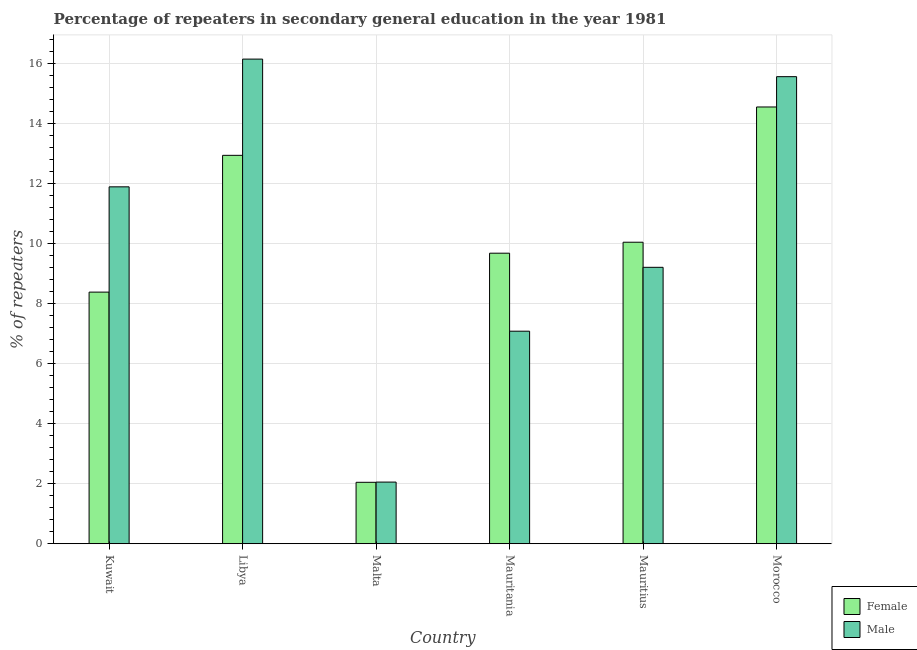How many groups of bars are there?
Give a very brief answer. 6. Are the number of bars on each tick of the X-axis equal?
Your response must be concise. Yes. How many bars are there on the 3rd tick from the left?
Ensure brevity in your answer.  2. What is the label of the 4th group of bars from the left?
Make the answer very short. Mauritania. In how many cases, is the number of bars for a given country not equal to the number of legend labels?
Provide a succinct answer. 0. What is the percentage of male repeaters in Malta?
Provide a succinct answer. 2.05. Across all countries, what is the maximum percentage of male repeaters?
Make the answer very short. 16.13. Across all countries, what is the minimum percentage of female repeaters?
Make the answer very short. 2.05. In which country was the percentage of female repeaters maximum?
Your response must be concise. Morocco. In which country was the percentage of female repeaters minimum?
Keep it short and to the point. Malta. What is the total percentage of male repeaters in the graph?
Give a very brief answer. 61.89. What is the difference between the percentage of male repeaters in Kuwait and that in Mauritius?
Offer a terse response. 2.68. What is the difference between the percentage of female repeaters in Mauritania and the percentage of male repeaters in Morocco?
Ensure brevity in your answer.  -5.88. What is the average percentage of male repeaters per country?
Ensure brevity in your answer.  10.32. What is the difference between the percentage of female repeaters and percentage of male repeaters in Malta?
Provide a short and direct response. -0.01. In how many countries, is the percentage of male repeaters greater than 14.8 %?
Ensure brevity in your answer.  2. What is the ratio of the percentage of male repeaters in Libya to that in Malta?
Ensure brevity in your answer.  7.86. Is the percentage of female repeaters in Kuwait less than that in Morocco?
Provide a succinct answer. Yes. What is the difference between the highest and the second highest percentage of male repeaters?
Make the answer very short. 0.58. What is the difference between the highest and the lowest percentage of female repeaters?
Offer a very short reply. 12.49. Are all the bars in the graph horizontal?
Provide a succinct answer. No. How many countries are there in the graph?
Make the answer very short. 6. What is the difference between two consecutive major ticks on the Y-axis?
Give a very brief answer. 2. Are the values on the major ticks of Y-axis written in scientific E-notation?
Provide a short and direct response. No. Does the graph contain any zero values?
Your answer should be very brief. No. What is the title of the graph?
Make the answer very short. Percentage of repeaters in secondary general education in the year 1981. Does "By country of asylum" appear as one of the legend labels in the graph?
Make the answer very short. No. What is the label or title of the X-axis?
Provide a short and direct response. Country. What is the label or title of the Y-axis?
Provide a short and direct response. % of repeaters. What is the % of repeaters of Female in Kuwait?
Your answer should be very brief. 8.38. What is the % of repeaters of Male in Kuwait?
Offer a very short reply. 11.88. What is the % of repeaters of Female in Libya?
Your answer should be very brief. 12.93. What is the % of repeaters in Male in Libya?
Provide a succinct answer. 16.13. What is the % of repeaters of Female in Malta?
Ensure brevity in your answer.  2.05. What is the % of repeaters of Male in Malta?
Ensure brevity in your answer.  2.05. What is the % of repeaters in Female in Mauritania?
Offer a very short reply. 9.67. What is the % of repeaters in Male in Mauritania?
Your response must be concise. 7.08. What is the % of repeaters in Female in Mauritius?
Offer a very short reply. 10.04. What is the % of repeaters in Male in Mauritius?
Your answer should be very brief. 9.2. What is the % of repeaters of Female in Morocco?
Your answer should be compact. 14.54. What is the % of repeaters of Male in Morocco?
Provide a succinct answer. 15.55. Across all countries, what is the maximum % of repeaters in Female?
Give a very brief answer. 14.54. Across all countries, what is the maximum % of repeaters of Male?
Ensure brevity in your answer.  16.13. Across all countries, what is the minimum % of repeaters of Female?
Your answer should be compact. 2.05. Across all countries, what is the minimum % of repeaters of Male?
Provide a succinct answer. 2.05. What is the total % of repeaters of Female in the graph?
Your answer should be very brief. 57.6. What is the total % of repeaters of Male in the graph?
Offer a very short reply. 61.89. What is the difference between the % of repeaters in Female in Kuwait and that in Libya?
Ensure brevity in your answer.  -4.55. What is the difference between the % of repeaters in Male in Kuwait and that in Libya?
Offer a very short reply. -4.25. What is the difference between the % of repeaters of Female in Kuwait and that in Malta?
Give a very brief answer. 6.33. What is the difference between the % of repeaters in Male in Kuwait and that in Malta?
Provide a succinct answer. 9.83. What is the difference between the % of repeaters of Female in Kuwait and that in Mauritania?
Give a very brief answer. -1.3. What is the difference between the % of repeaters of Male in Kuwait and that in Mauritania?
Give a very brief answer. 4.81. What is the difference between the % of repeaters in Female in Kuwait and that in Mauritius?
Make the answer very short. -1.66. What is the difference between the % of repeaters of Male in Kuwait and that in Mauritius?
Provide a short and direct response. 2.68. What is the difference between the % of repeaters in Female in Kuwait and that in Morocco?
Provide a short and direct response. -6.16. What is the difference between the % of repeaters in Male in Kuwait and that in Morocco?
Provide a short and direct response. -3.67. What is the difference between the % of repeaters in Female in Libya and that in Malta?
Offer a very short reply. 10.88. What is the difference between the % of repeaters in Male in Libya and that in Malta?
Offer a terse response. 14.08. What is the difference between the % of repeaters of Female in Libya and that in Mauritania?
Provide a short and direct response. 3.26. What is the difference between the % of repeaters in Male in Libya and that in Mauritania?
Provide a succinct answer. 9.06. What is the difference between the % of repeaters of Female in Libya and that in Mauritius?
Offer a very short reply. 2.89. What is the difference between the % of repeaters in Male in Libya and that in Mauritius?
Ensure brevity in your answer.  6.93. What is the difference between the % of repeaters in Female in Libya and that in Morocco?
Your answer should be compact. -1.61. What is the difference between the % of repeaters of Male in Libya and that in Morocco?
Your answer should be compact. 0.58. What is the difference between the % of repeaters in Female in Malta and that in Mauritania?
Your answer should be very brief. -7.63. What is the difference between the % of repeaters in Male in Malta and that in Mauritania?
Give a very brief answer. -5.02. What is the difference between the % of repeaters of Female in Malta and that in Mauritius?
Make the answer very short. -7.99. What is the difference between the % of repeaters of Male in Malta and that in Mauritius?
Offer a terse response. -7.15. What is the difference between the % of repeaters in Female in Malta and that in Morocco?
Ensure brevity in your answer.  -12.49. What is the difference between the % of repeaters of Male in Malta and that in Morocco?
Make the answer very short. -13.5. What is the difference between the % of repeaters in Female in Mauritania and that in Mauritius?
Give a very brief answer. -0.37. What is the difference between the % of repeaters in Male in Mauritania and that in Mauritius?
Offer a terse response. -2.13. What is the difference between the % of repeaters of Female in Mauritania and that in Morocco?
Your response must be concise. -4.87. What is the difference between the % of repeaters of Male in Mauritania and that in Morocco?
Make the answer very short. -8.47. What is the difference between the % of repeaters in Female in Mauritius and that in Morocco?
Provide a short and direct response. -4.5. What is the difference between the % of repeaters of Male in Mauritius and that in Morocco?
Keep it short and to the point. -6.35. What is the difference between the % of repeaters of Female in Kuwait and the % of repeaters of Male in Libya?
Offer a terse response. -7.76. What is the difference between the % of repeaters of Female in Kuwait and the % of repeaters of Male in Malta?
Offer a very short reply. 6.32. What is the difference between the % of repeaters of Female in Kuwait and the % of repeaters of Male in Mauritania?
Offer a very short reply. 1.3. What is the difference between the % of repeaters of Female in Kuwait and the % of repeaters of Male in Mauritius?
Provide a short and direct response. -0.83. What is the difference between the % of repeaters in Female in Kuwait and the % of repeaters in Male in Morocco?
Your answer should be compact. -7.17. What is the difference between the % of repeaters in Female in Libya and the % of repeaters in Male in Malta?
Keep it short and to the point. 10.88. What is the difference between the % of repeaters of Female in Libya and the % of repeaters of Male in Mauritania?
Make the answer very short. 5.85. What is the difference between the % of repeaters of Female in Libya and the % of repeaters of Male in Mauritius?
Ensure brevity in your answer.  3.73. What is the difference between the % of repeaters in Female in Libya and the % of repeaters in Male in Morocco?
Your answer should be very brief. -2.62. What is the difference between the % of repeaters of Female in Malta and the % of repeaters of Male in Mauritania?
Provide a succinct answer. -5.03. What is the difference between the % of repeaters of Female in Malta and the % of repeaters of Male in Mauritius?
Provide a succinct answer. -7.16. What is the difference between the % of repeaters of Female in Malta and the % of repeaters of Male in Morocco?
Provide a short and direct response. -13.5. What is the difference between the % of repeaters of Female in Mauritania and the % of repeaters of Male in Mauritius?
Make the answer very short. 0.47. What is the difference between the % of repeaters in Female in Mauritania and the % of repeaters in Male in Morocco?
Offer a terse response. -5.88. What is the difference between the % of repeaters of Female in Mauritius and the % of repeaters of Male in Morocco?
Make the answer very short. -5.51. What is the average % of repeaters of Female per country?
Your answer should be very brief. 9.6. What is the average % of repeaters of Male per country?
Ensure brevity in your answer.  10.32. What is the difference between the % of repeaters of Female and % of repeaters of Male in Kuwait?
Offer a very short reply. -3.5. What is the difference between the % of repeaters of Female and % of repeaters of Male in Libya?
Give a very brief answer. -3.2. What is the difference between the % of repeaters in Female and % of repeaters in Male in Malta?
Provide a short and direct response. -0.01. What is the difference between the % of repeaters in Female and % of repeaters in Male in Mauritania?
Offer a very short reply. 2.6. What is the difference between the % of repeaters of Female and % of repeaters of Male in Mauritius?
Give a very brief answer. 0.84. What is the difference between the % of repeaters in Female and % of repeaters in Male in Morocco?
Give a very brief answer. -1.01. What is the ratio of the % of repeaters in Female in Kuwait to that in Libya?
Ensure brevity in your answer.  0.65. What is the ratio of the % of repeaters in Male in Kuwait to that in Libya?
Provide a short and direct response. 0.74. What is the ratio of the % of repeaters of Female in Kuwait to that in Malta?
Your answer should be compact. 4.1. What is the ratio of the % of repeaters in Male in Kuwait to that in Malta?
Offer a terse response. 5.79. What is the ratio of the % of repeaters in Female in Kuwait to that in Mauritania?
Offer a terse response. 0.87. What is the ratio of the % of repeaters in Male in Kuwait to that in Mauritania?
Provide a short and direct response. 1.68. What is the ratio of the % of repeaters in Female in Kuwait to that in Mauritius?
Your response must be concise. 0.83. What is the ratio of the % of repeaters in Male in Kuwait to that in Mauritius?
Ensure brevity in your answer.  1.29. What is the ratio of the % of repeaters in Female in Kuwait to that in Morocco?
Ensure brevity in your answer.  0.58. What is the ratio of the % of repeaters of Male in Kuwait to that in Morocco?
Offer a very short reply. 0.76. What is the ratio of the % of repeaters of Female in Libya to that in Malta?
Ensure brevity in your answer.  6.32. What is the ratio of the % of repeaters of Male in Libya to that in Malta?
Give a very brief answer. 7.86. What is the ratio of the % of repeaters in Female in Libya to that in Mauritania?
Keep it short and to the point. 1.34. What is the ratio of the % of repeaters in Male in Libya to that in Mauritania?
Provide a short and direct response. 2.28. What is the ratio of the % of repeaters of Female in Libya to that in Mauritius?
Give a very brief answer. 1.29. What is the ratio of the % of repeaters in Male in Libya to that in Mauritius?
Give a very brief answer. 1.75. What is the ratio of the % of repeaters in Female in Libya to that in Morocco?
Your answer should be compact. 0.89. What is the ratio of the % of repeaters of Male in Libya to that in Morocco?
Your answer should be compact. 1.04. What is the ratio of the % of repeaters in Female in Malta to that in Mauritania?
Give a very brief answer. 0.21. What is the ratio of the % of repeaters in Male in Malta to that in Mauritania?
Give a very brief answer. 0.29. What is the ratio of the % of repeaters in Female in Malta to that in Mauritius?
Your answer should be very brief. 0.2. What is the ratio of the % of repeaters in Male in Malta to that in Mauritius?
Your answer should be very brief. 0.22. What is the ratio of the % of repeaters in Female in Malta to that in Morocco?
Provide a short and direct response. 0.14. What is the ratio of the % of repeaters of Male in Malta to that in Morocco?
Your answer should be compact. 0.13. What is the ratio of the % of repeaters of Female in Mauritania to that in Mauritius?
Offer a terse response. 0.96. What is the ratio of the % of repeaters of Male in Mauritania to that in Mauritius?
Keep it short and to the point. 0.77. What is the ratio of the % of repeaters in Female in Mauritania to that in Morocco?
Offer a terse response. 0.67. What is the ratio of the % of repeaters in Male in Mauritania to that in Morocco?
Keep it short and to the point. 0.46. What is the ratio of the % of repeaters of Female in Mauritius to that in Morocco?
Keep it short and to the point. 0.69. What is the ratio of the % of repeaters of Male in Mauritius to that in Morocco?
Offer a terse response. 0.59. What is the difference between the highest and the second highest % of repeaters in Female?
Provide a succinct answer. 1.61. What is the difference between the highest and the second highest % of repeaters in Male?
Your response must be concise. 0.58. What is the difference between the highest and the lowest % of repeaters in Female?
Ensure brevity in your answer.  12.49. What is the difference between the highest and the lowest % of repeaters of Male?
Your response must be concise. 14.08. 